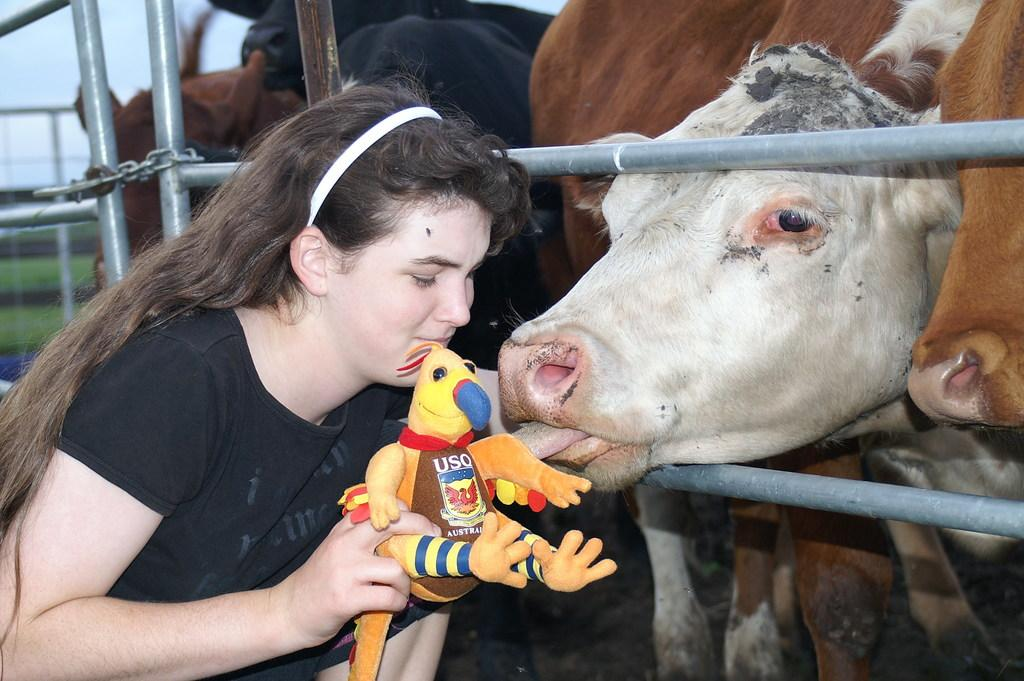What types of living organisms can be seen in the image? There are animals in the image. Can you describe the woman in the image? The woman is in the image, and she is wearing a black color T-shirt. What is the woman holding in her hands? The woman is holding an object in her hands. What structures can be seen in the image? There is a fence and a chain in the image. What type of honey can be seen dripping from the chain in the image? There is no honey present in the image; it features animals, a woman, and a chain. 